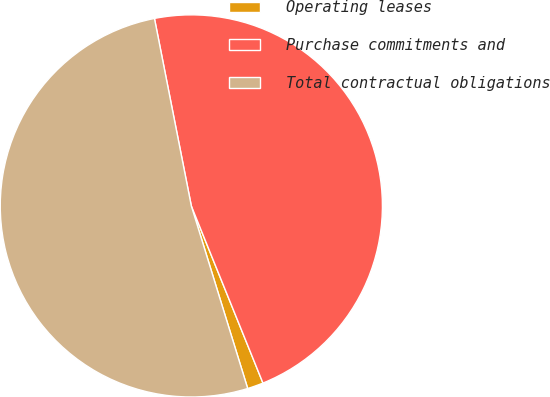<chart> <loc_0><loc_0><loc_500><loc_500><pie_chart><fcel>Operating leases<fcel>Purchase commitments and<fcel>Total contractual obligations<nl><fcel>1.35%<fcel>46.97%<fcel>51.67%<nl></chart> 